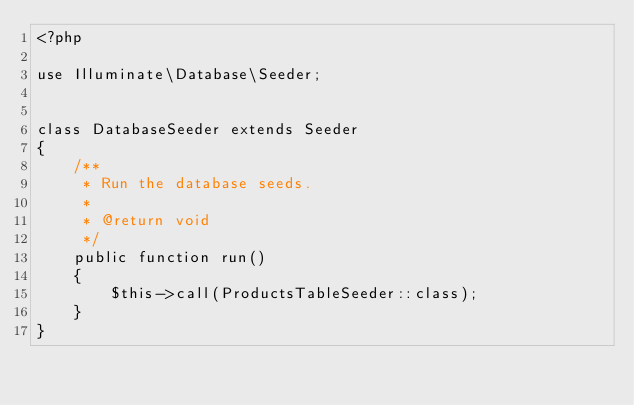Convert code to text. <code><loc_0><loc_0><loc_500><loc_500><_PHP_><?php

use Illuminate\Database\Seeder;


class DatabaseSeeder extends Seeder
{
    /**
     * Run the database seeds.
     *
     * @return void
     */
    public function run()
    {
        $this->call(ProductsTableSeeder::class);
    }
}
</code> 